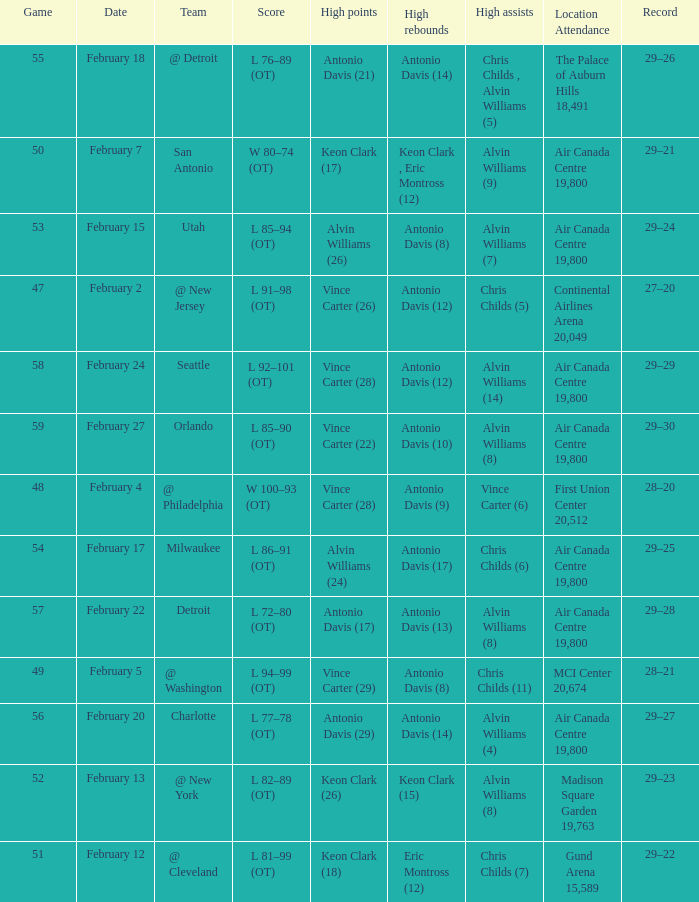What is the Team with a game of more than 56, and the score is l 85–90 (ot)? Orlando. 